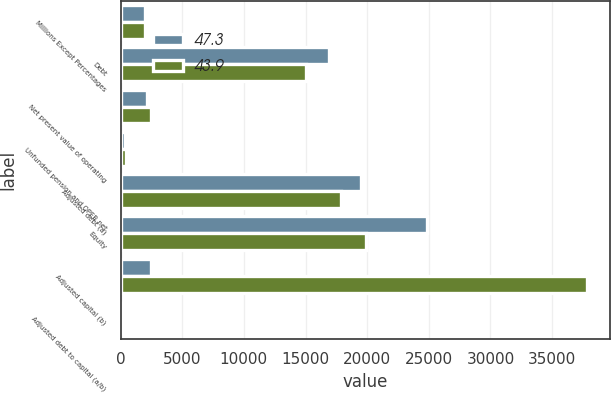Convert chart to OTSL. <chart><loc_0><loc_0><loc_500><loc_500><stacked_bar_chart><ecel><fcel>Millions Except Percentages<fcel>Debt<fcel>Net present value of operating<fcel>Unfunded pension and OPEB net<fcel>Adjusted debt (a)<fcel>Equity<fcel>Adjusted capital (b)<fcel>Adjusted debt to capital (a/b)<nl><fcel>47.3<fcel>2017<fcel>16944<fcel>2140<fcel>396<fcel>19480<fcel>24856<fcel>2435<fcel>43.9<nl><fcel>43.9<fcel>2016<fcel>15007<fcel>2435<fcel>436<fcel>17878<fcel>19932<fcel>37810<fcel>47.3<nl></chart> 